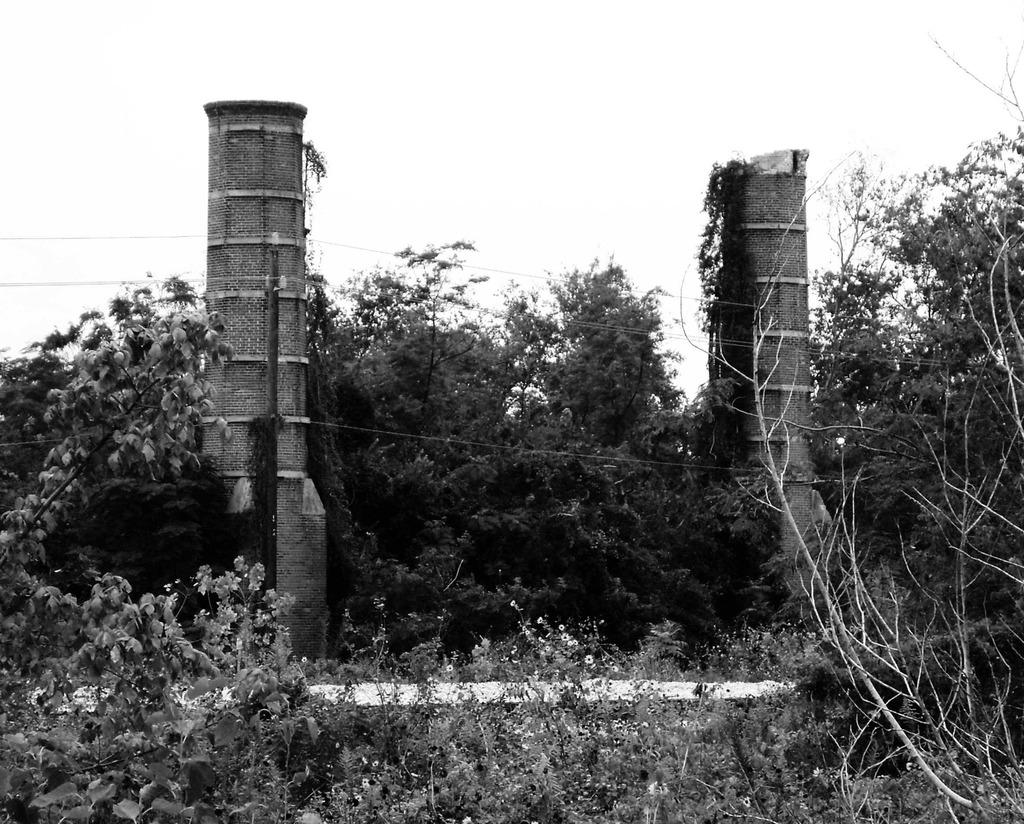What structures are present in the image? There are pillars and current poles in the image. What else can be seen in the image besides the structures? There are wires and trees visible in the image. What is visible in the background of the image? The sky is visible in the image. What is the color scheme of the image? The image is in black and white. Where is the nearest fire station to the location depicted in the image? The image does not provide information about the location or the presence of a fire station, so it cannot be determined from the image. What type of fog can be seen in the image? There is no fog present in the image; it is in black and white and shows pillars, current poles, wires, trees, and the sky. 